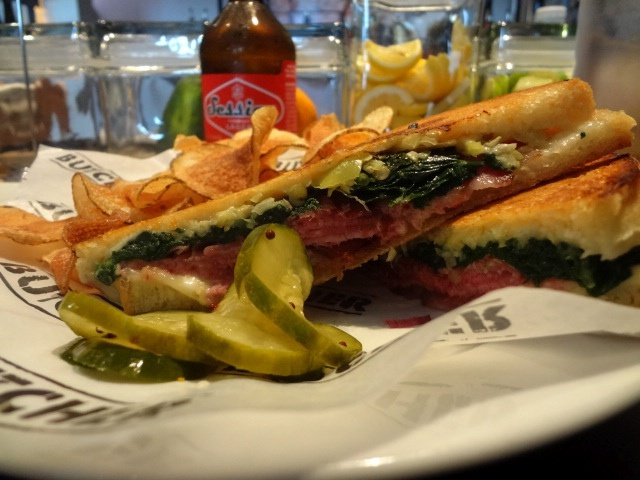Describe the objects in this image and their specific colors. I can see hot dog in gray, maroon, black, and olive tones, bottle in gray, brown, black, and maroon tones, and orange in gray, olive, and tan tones in this image. 